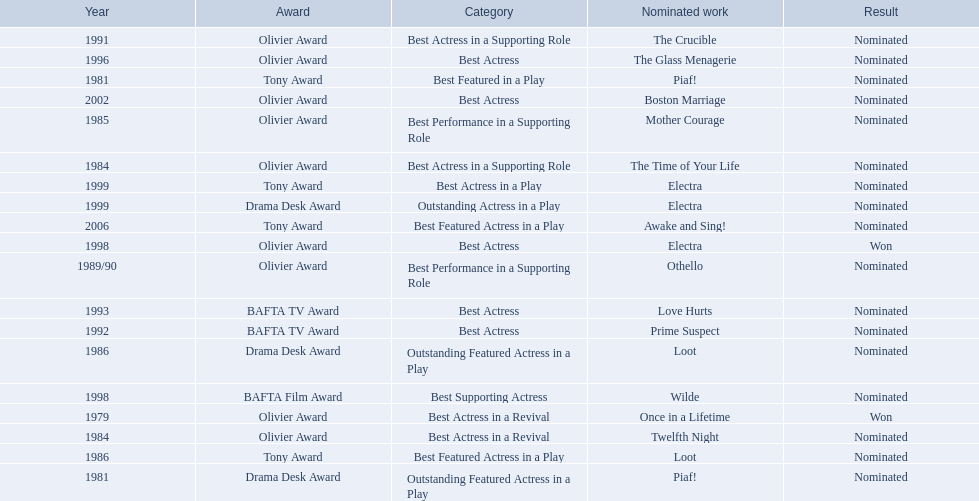Which works were nominated for the oliver award? Twelfth Night, The Time of Your Life, Mother Courage, Othello, The Crucible, The Glass Menagerie, Electra, Boston Marriage. Of these which ones did not win? Twelfth Night, The Time of Your Life, Mother Courage, Othello, The Crucible, The Glass Menagerie, Boston Marriage. Which of those were nominated for best actress of any kind in the 1080s? Twelfth Night, The Time of Your Life. Which of these was a revival? Twelfth Night. 